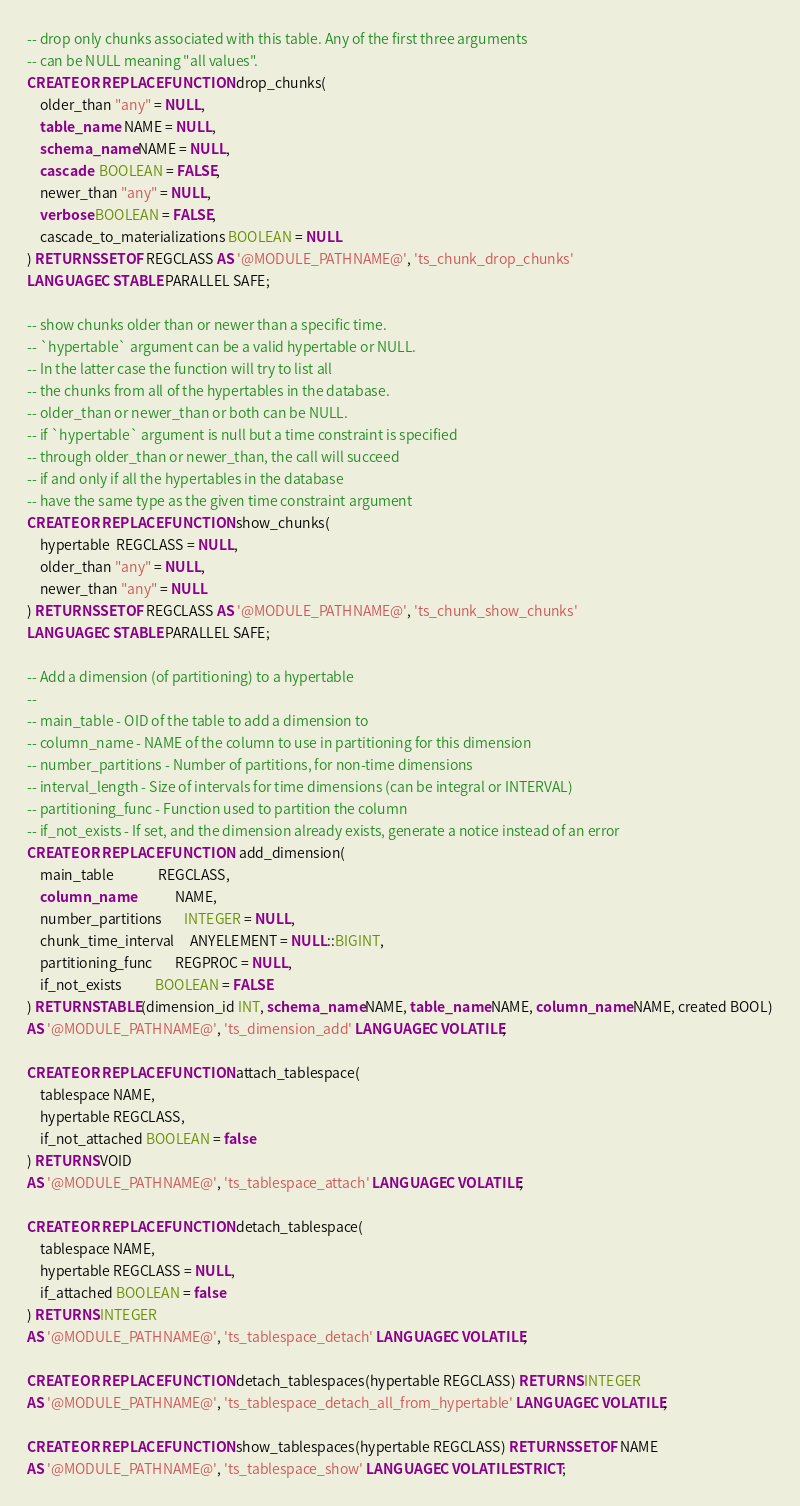Convert code to text. <code><loc_0><loc_0><loc_500><loc_500><_SQL_>-- drop only chunks associated with this table. Any of the first three arguments
-- can be NULL meaning "all values".
CREATE OR REPLACE FUNCTION drop_chunks(
    older_than "any" = NULL,
    table_name  NAME = NULL,
    schema_name NAME = NULL,
    cascade  BOOLEAN = FALSE,
    newer_than "any" = NULL,
    verbose BOOLEAN = FALSE,
    cascade_to_materializations BOOLEAN = NULL
) RETURNS SETOF REGCLASS AS '@MODULE_PATHNAME@', 'ts_chunk_drop_chunks'
LANGUAGE C STABLE PARALLEL SAFE;

-- show chunks older than or newer than a specific time.
-- `hypertable` argument can be a valid hypertable or NULL.
-- In the latter case the function will try to list all
-- the chunks from all of the hypertables in the database.
-- older_than or newer_than or both can be NULL.
-- if `hypertable` argument is null but a time constraint is specified
-- through older_than or newer_than, the call will succeed
-- if and only if all the hypertables in the database
-- have the same type as the given time constraint argument
CREATE OR REPLACE FUNCTION show_chunks(
    hypertable  REGCLASS = NULL,
    older_than "any" = NULL,
    newer_than "any" = NULL
) RETURNS SETOF REGCLASS AS '@MODULE_PATHNAME@', 'ts_chunk_show_chunks'
LANGUAGE C STABLE PARALLEL SAFE;

-- Add a dimension (of partitioning) to a hypertable
--
-- main_table - OID of the table to add a dimension to
-- column_name - NAME of the column to use in partitioning for this dimension
-- number_partitions - Number of partitions, for non-time dimensions
-- interval_length - Size of intervals for time dimensions (can be integral or INTERVAL)
-- partitioning_func - Function used to partition the column
-- if_not_exists - If set, and the dimension already exists, generate a notice instead of an error
CREATE OR REPLACE FUNCTION  add_dimension(
    main_table              REGCLASS,
    column_name             NAME,
    number_partitions       INTEGER = NULL,
    chunk_time_interval     ANYELEMENT = NULL::BIGINT,
    partitioning_func       REGPROC = NULL,
    if_not_exists           BOOLEAN = FALSE
) RETURNS TABLE(dimension_id INT, schema_name NAME, table_name NAME, column_name NAME, created BOOL)
AS '@MODULE_PATHNAME@', 'ts_dimension_add' LANGUAGE C VOLATILE;

CREATE OR REPLACE FUNCTION attach_tablespace(
    tablespace NAME,
    hypertable REGCLASS,
    if_not_attached BOOLEAN = false
) RETURNS VOID
AS '@MODULE_PATHNAME@', 'ts_tablespace_attach' LANGUAGE C VOLATILE;

CREATE OR REPLACE FUNCTION detach_tablespace(
    tablespace NAME,
    hypertable REGCLASS = NULL,
    if_attached BOOLEAN = false
) RETURNS INTEGER
AS '@MODULE_PATHNAME@', 'ts_tablespace_detach' LANGUAGE C VOLATILE;

CREATE OR REPLACE FUNCTION detach_tablespaces(hypertable REGCLASS) RETURNS INTEGER
AS '@MODULE_PATHNAME@', 'ts_tablespace_detach_all_from_hypertable' LANGUAGE C VOLATILE;

CREATE OR REPLACE FUNCTION show_tablespaces(hypertable REGCLASS) RETURNS SETOF NAME
AS '@MODULE_PATHNAME@', 'ts_tablespace_show' LANGUAGE C VOLATILE STRICT;
</code> 